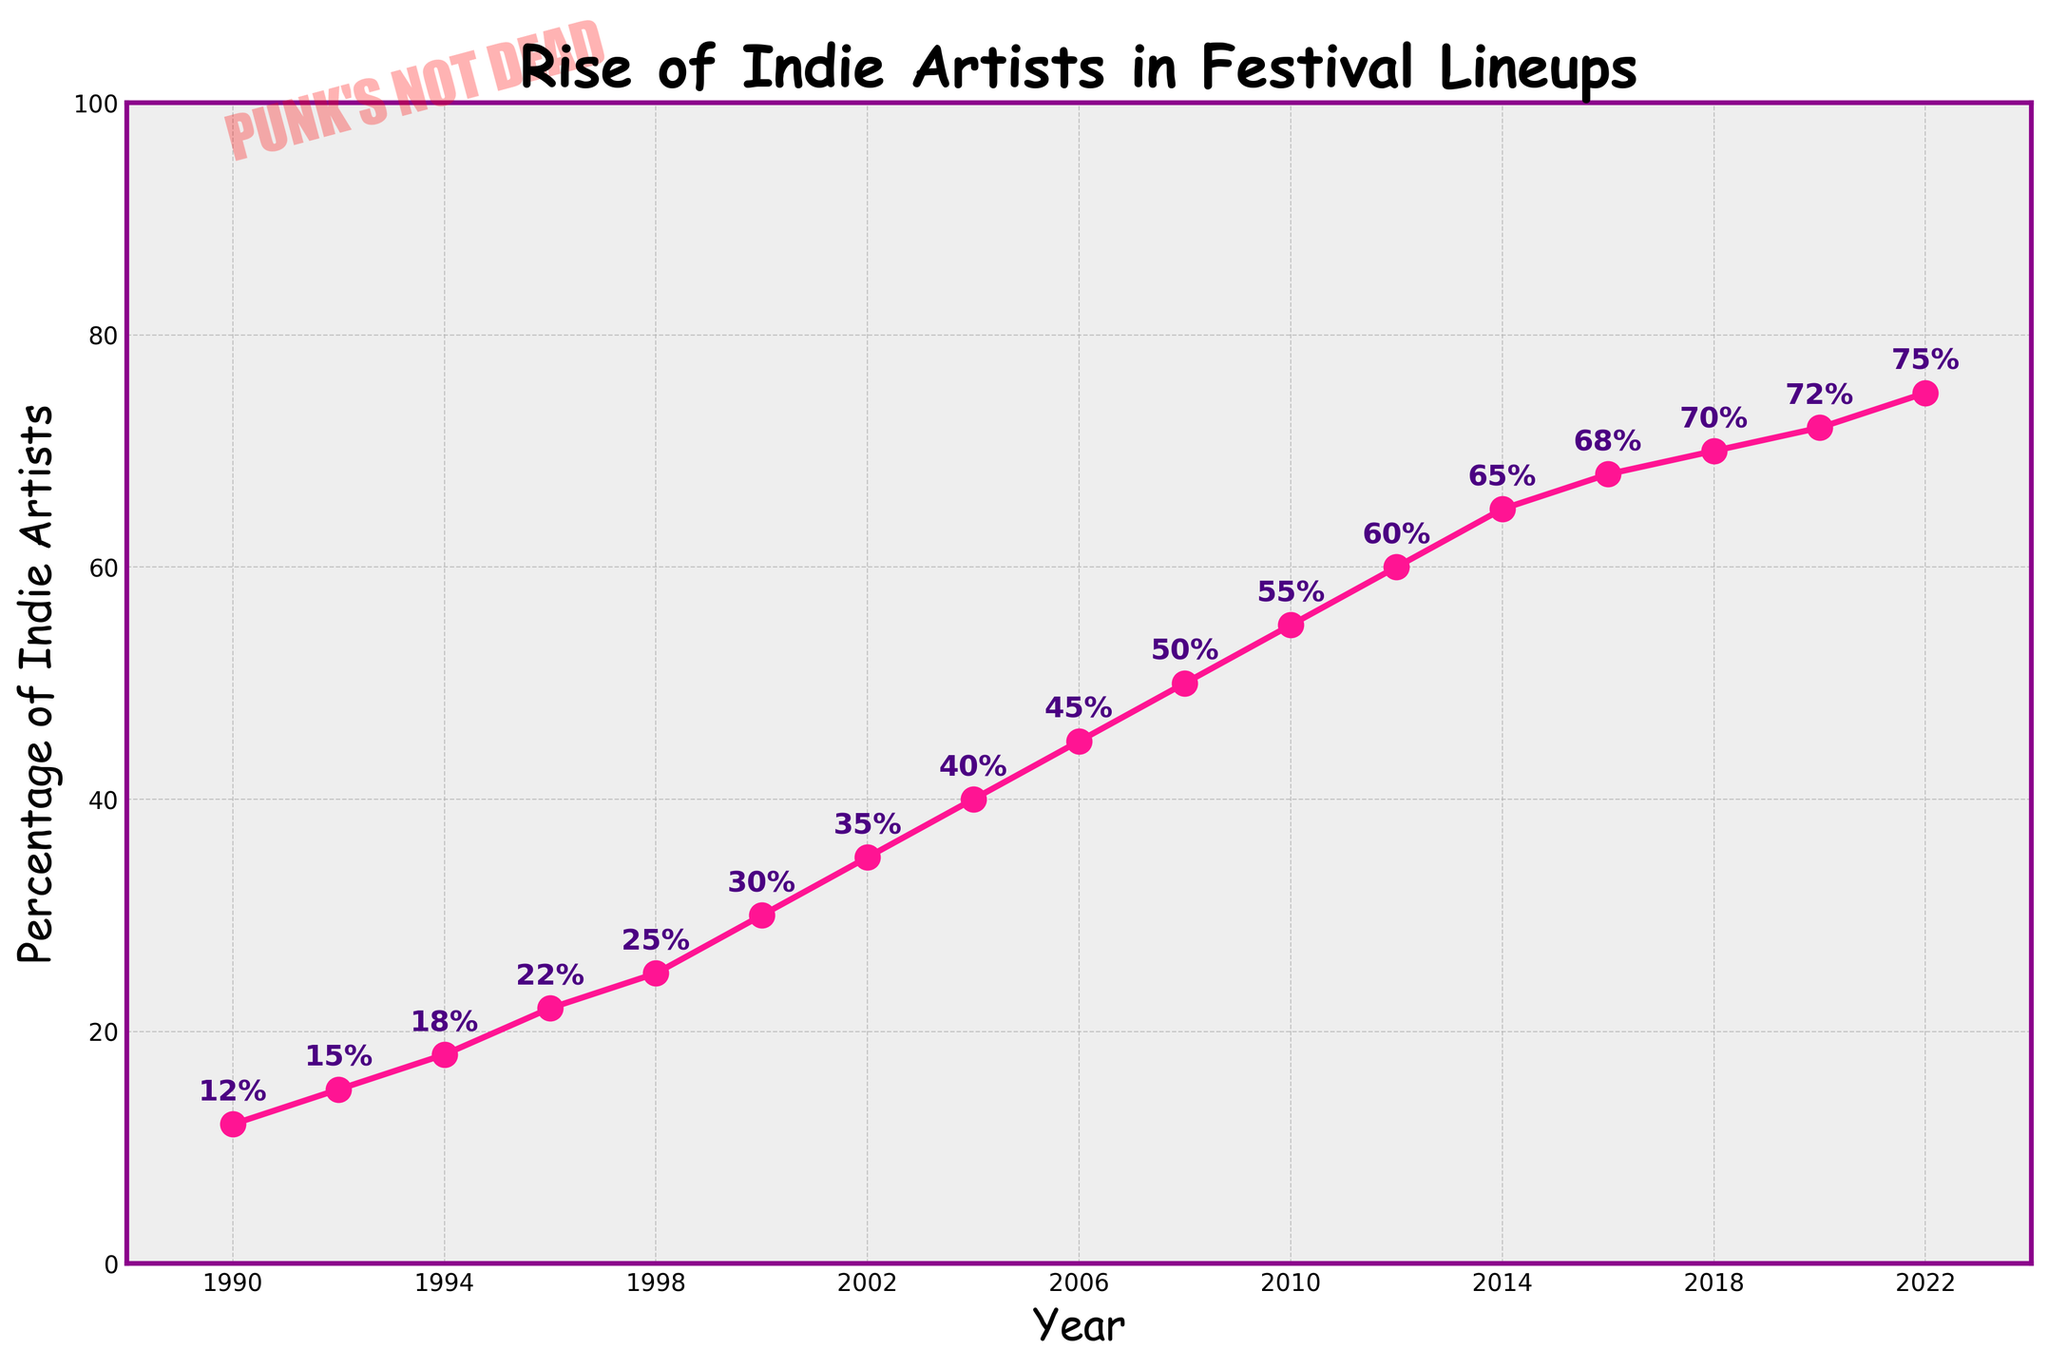What is the percentage of indie artists in 2010? According to the figure, locate the year 2010 on the x-axis and read the corresponding y-axis value for the percentage.
Answer: 55% How much did the percentage of indie artists increase between 1990 and 2000? In 1990, the percentage was 12%, and in 2000, it was 30%. Subtract the 1990 value from the 2000 value (30 - 12).
Answer: 18% Which year saw the highest percentage of indie artists? Identify the highest point on the y-axis within the plotted data points and find the corresponding year on the x-axis.
Answer: 2022 What was the increase in percentage from 2000 to 2008? In 2000, the percentage was 30%, and in 2008, it was 50%. Subtract the 2000 value from the 2008 value (50 - 30).
Answer: 20% Between which consecutive years did the percentage increase the most? Compare the difference in percentage values between each consecutive year pair, and identify the pair with the greatest difference. The increase was greatest from 2010 to 2012.
Answer: 2010 to 2012 How has the trend in indie artist percentages changed from 1990 to 2022? Examine the slope of the line from 1990 to 2022; it shows a steady upward trend, indicating a consistent increase in the percentage of indie artists.
Answer: Consistently increased What was the average percentage of indie artists from 1990 to 2000? Sum the percentages from 1990, 1992, 1994, 1996, 1998, and 2000 (12 + 15 + 18 + 22 + 25 + 30) and divide by the number of data points (6).
Answer: 20.3% Was there any year when the percentage remained the same as the previous year? Review the plot for any horizontal lines, which would indicate no change between consecutive years. There are no such lines, so the percentage changed every year.
Answer: No How does the color of the line in the chart enhance the visualization? The line color is mentioned as pink/magenta. It enhances visibility by standing out clearly against the background, making it easier to follow the trend.
Answer: Enhances visibility 